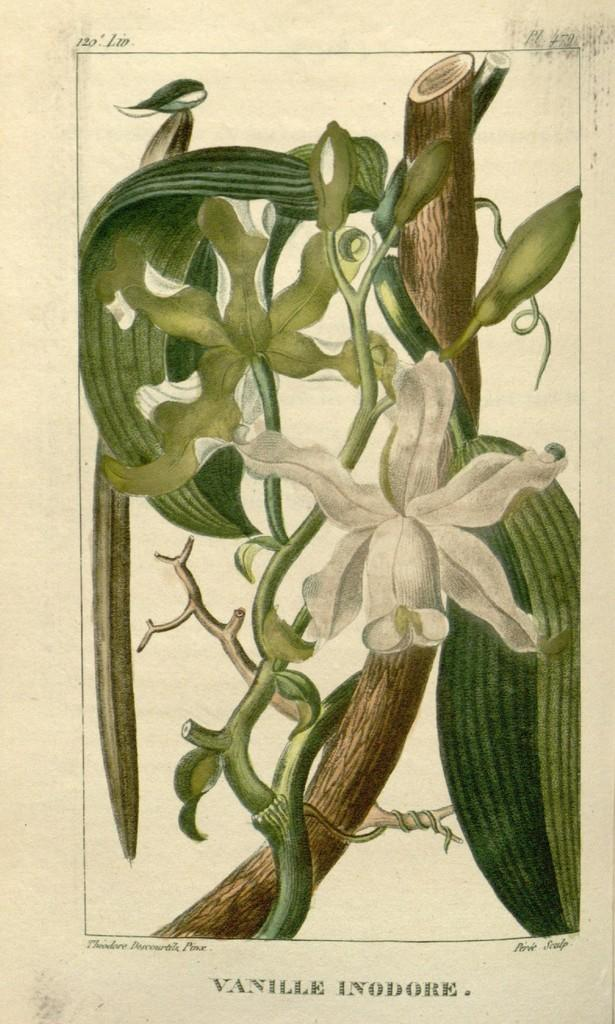What is the main subject of the image? The main subject of the image is a depiction of a plant. What else is present in the image besides the plant? There is some text in the image. What type of kite is being flown by the beggar in the image? There is no kite or beggar present in the image; it only features a depiction of a plant and some text. What color is the flag that the beggar is holding in the image? There is no flag or beggar present in the image. 